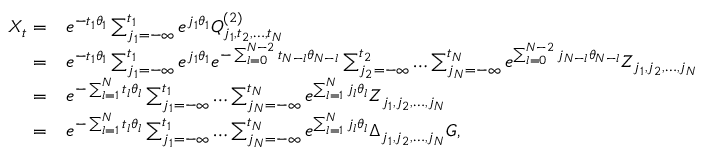Convert formula to latex. <formula><loc_0><loc_0><loc_500><loc_500>\begin{array} { r l } { X _ { t } = } & { e ^ { - t _ { 1 } \theta _ { 1 } } \sum _ { j _ { 1 } = - \infty } ^ { t _ { 1 } } e ^ { j _ { 1 } \theta _ { 1 } } Q _ { j _ { 1 } , t _ { 2 } , \dots , t _ { N } } ^ { ( 2 ) } } \\ { = } & { e ^ { - t _ { 1 } \theta _ { 1 } } \sum _ { j _ { 1 } = - \infty } ^ { t _ { 1 } } e ^ { j _ { 1 } \theta _ { 1 } } e ^ { - \sum _ { l = 0 } ^ { N - 2 } t _ { N - l } \theta _ { N - l } } \sum _ { j _ { 2 } = - \infty } ^ { t _ { 2 } } \dots \sum _ { j _ { N } = - \infty } ^ { t _ { N } } e ^ { \sum _ { l = 0 } ^ { N - 2 } j _ { N - l } \theta _ { N - l } } Z _ { j _ { 1 } , j _ { 2 } , \dots , j _ { N } } } \\ { = } & { e ^ { - \sum _ { l = 1 } ^ { N } t _ { l } \theta _ { l } } \sum _ { j _ { 1 } = - \infty } ^ { t _ { 1 } } \dots \sum _ { j _ { N } = - \infty } ^ { t _ { N } } e ^ { \sum _ { l = 1 } ^ { N } j _ { l } \theta _ { l } } Z _ { j _ { 1 } , j _ { 2 } , \dots , j _ { N } } } \\ { = } & { e ^ { - \sum _ { l = 1 } ^ { N } t _ { l } \theta _ { l } } \sum _ { j _ { 1 } = - \infty } ^ { t _ { 1 } } \dots \sum _ { j _ { N } = - \infty } ^ { t _ { N } } e ^ { \sum _ { l = 1 } ^ { N } j _ { l } \theta _ { l } } \Delta _ { j _ { 1 } , j _ { 2 } , \dots , j _ { N } } G , } \end{array}</formula> 